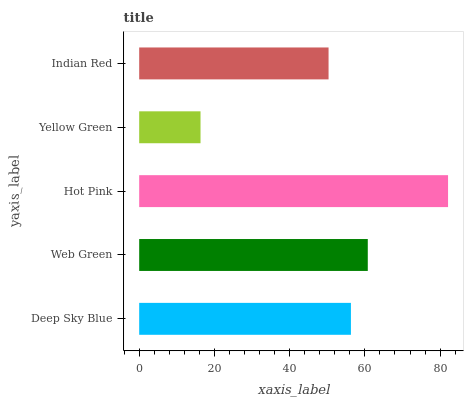Is Yellow Green the minimum?
Answer yes or no. Yes. Is Hot Pink the maximum?
Answer yes or no. Yes. Is Web Green the minimum?
Answer yes or no. No. Is Web Green the maximum?
Answer yes or no. No. Is Web Green greater than Deep Sky Blue?
Answer yes or no. Yes. Is Deep Sky Blue less than Web Green?
Answer yes or no. Yes. Is Deep Sky Blue greater than Web Green?
Answer yes or no. No. Is Web Green less than Deep Sky Blue?
Answer yes or no. No. Is Deep Sky Blue the high median?
Answer yes or no. Yes. Is Deep Sky Blue the low median?
Answer yes or no. Yes. Is Web Green the high median?
Answer yes or no. No. Is Web Green the low median?
Answer yes or no. No. 